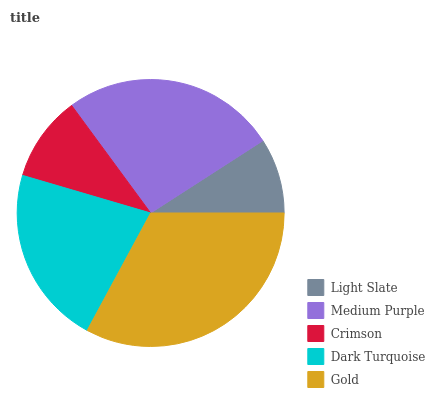Is Light Slate the minimum?
Answer yes or no. Yes. Is Gold the maximum?
Answer yes or no. Yes. Is Medium Purple the minimum?
Answer yes or no. No. Is Medium Purple the maximum?
Answer yes or no. No. Is Medium Purple greater than Light Slate?
Answer yes or no. Yes. Is Light Slate less than Medium Purple?
Answer yes or no. Yes. Is Light Slate greater than Medium Purple?
Answer yes or no. No. Is Medium Purple less than Light Slate?
Answer yes or no. No. Is Dark Turquoise the high median?
Answer yes or no. Yes. Is Dark Turquoise the low median?
Answer yes or no. Yes. Is Gold the high median?
Answer yes or no. No. Is Medium Purple the low median?
Answer yes or no. No. 